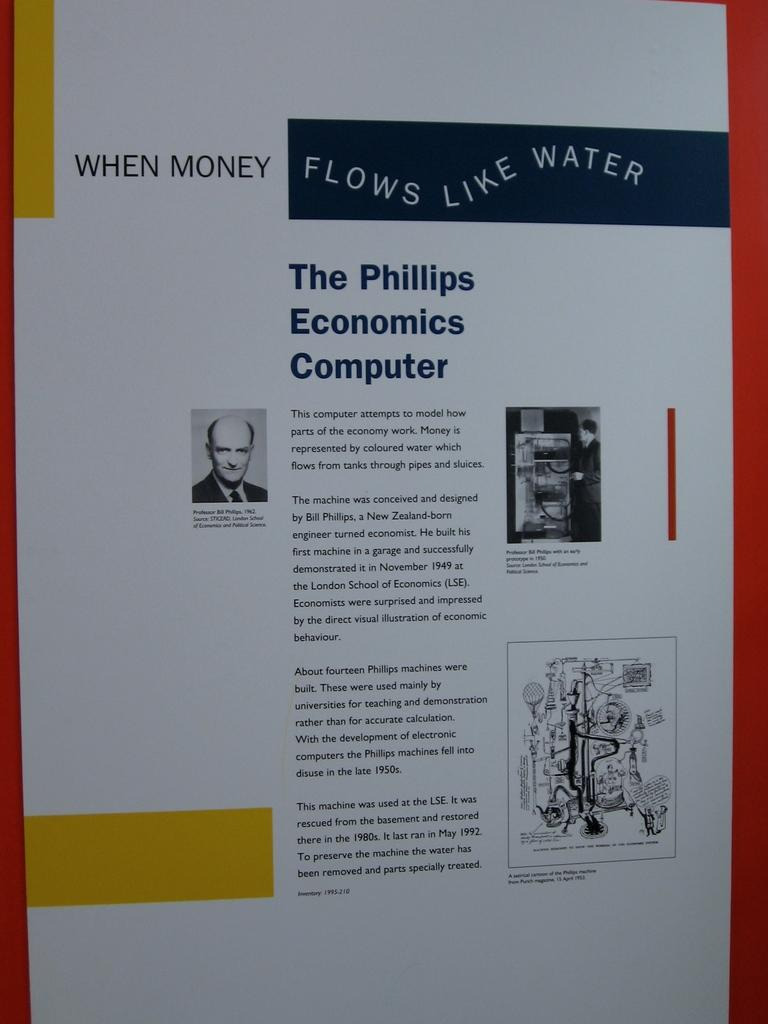<image>
Share a concise interpretation of the image provided. a paper that says 'flows like water' on it 